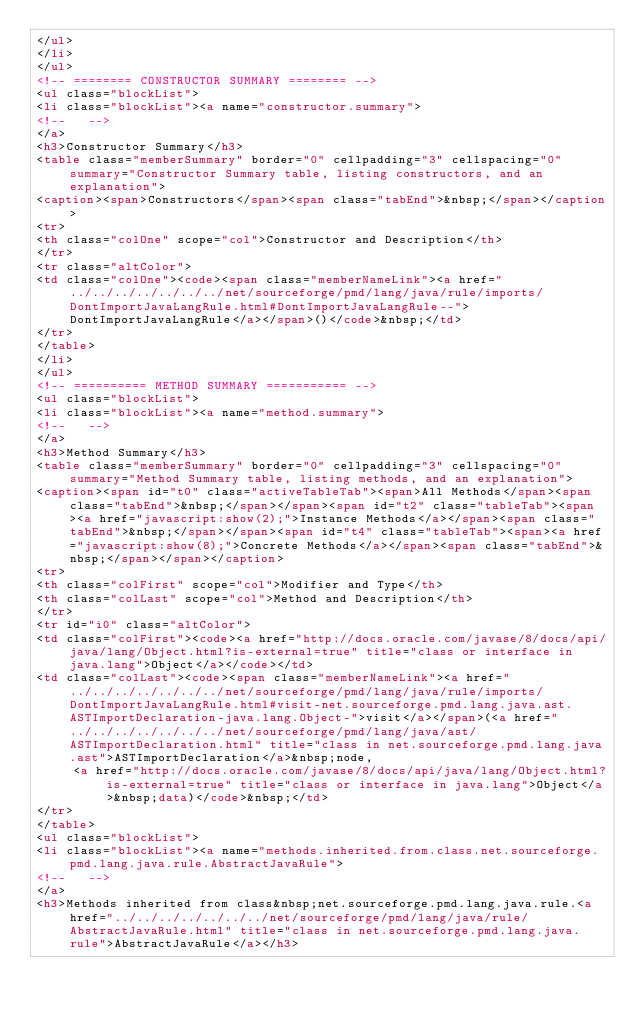<code> <loc_0><loc_0><loc_500><loc_500><_HTML_></ul>
</li>
</ul>
<!-- ======== CONSTRUCTOR SUMMARY ======== -->
<ul class="blockList">
<li class="blockList"><a name="constructor.summary">
<!--   -->
</a>
<h3>Constructor Summary</h3>
<table class="memberSummary" border="0" cellpadding="3" cellspacing="0" summary="Constructor Summary table, listing constructors, and an explanation">
<caption><span>Constructors</span><span class="tabEnd">&nbsp;</span></caption>
<tr>
<th class="colOne" scope="col">Constructor and Description</th>
</tr>
<tr class="altColor">
<td class="colOne"><code><span class="memberNameLink"><a href="../../../../../../../net/sourceforge/pmd/lang/java/rule/imports/DontImportJavaLangRule.html#DontImportJavaLangRule--">DontImportJavaLangRule</a></span>()</code>&nbsp;</td>
</tr>
</table>
</li>
</ul>
<!-- ========== METHOD SUMMARY =========== -->
<ul class="blockList">
<li class="blockList"><a name="method.summary">
<!--   -->
</a>
<h3>Method Summary</h3>
<table class="memberSummary" border="0" cellpadding="3" cellspacing="0" summary="Method Summary table, listing methods, and an explanation">
<caption><span id="t0" class="activeTableTab"><span>All Methods</span><span class="tabEnd">&nbsp;</span></span><span id="t2" class="tableTab"><span><a href="javascript:show(2);">Instance Methods</a></span><span class="tabEnd">&nbsp;</span></span><span id="t4" class="tableTab"><span><a href="javascript:show(8);">Concrete Methods</a></span><span class="tabEnd">&nbsp;</span></span></caption>
<tr>
<th class="colFirst" scope="col">Modifier and Type</th>
<th class="colLast" scope="col">Method and Description</th>
</tr>
<tr id="i0" class="altColor">
<td class="colFirst"><code><a href="http://docs.oracle.com/javase/8/docs/api/java/lang/Object.html?is-external=true" title="class or interface in java.lang">Object</a></code></td>
<td class="colLast"><code><span class="memberNameLink"><a href="../../../../../../../net/sourceforge/pmd/lang/java/rule/imports/DontImportJavaLangRule.html#visit-net.sourceforge.pmd.lang.java.ast.ASTImportDeclaration-java.lang.Object-">visit</a></span>(<a href="../../../../../../../net/sourceforge/pmd/lang/java/ast/ASTImportDeclaration.html" title="class in net.sourceforge.pmd.lang.java.ast">ASTImportDeclaration</a>&nbsp;node,
     <a href="http://docs.oracle.com/javase/8/docs/api/java/lang/Object.html?is-external=true" title="class or interface in java.lang">Object</a>&nbsp;data)</code>&nbsp;</td>
</tr>
</table>
<ul class="blockList">
<li class="blockList"><a name="methods.inherited.from.class.net.sourceforge.pmd.lang.java.rule.AbstractJavaRule">
<!--   -->
</a>
<h3>Methods inherited from class&nbsp;net.sourceforge.pmd.lang.java.rule.<a href="../../../../../../../net/sourceforge/pmd/lang/java/rule/AbstractJavaRule.html" title="class in net.sourceforge.pmd.lang.java.rule">AbstractJavaRule</a></h3></code> 